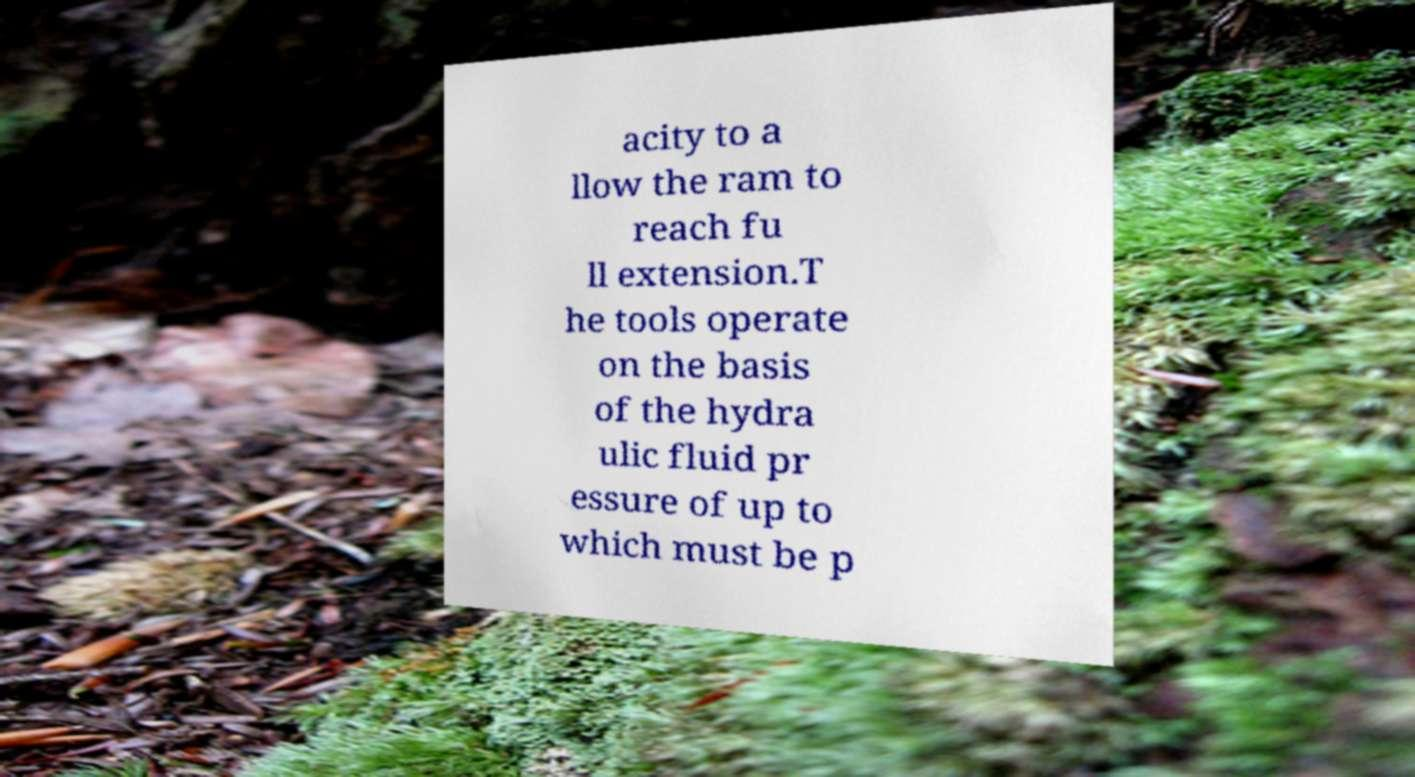Can you read and provide the text displayed in the image?This photo seems to have some interesting text. Can you extract and type it out for me? acity to a llow the ram to reach fu ll extension.T he tools operate on the basis of the hydra ulic fluid pr essure of up to which must be p 